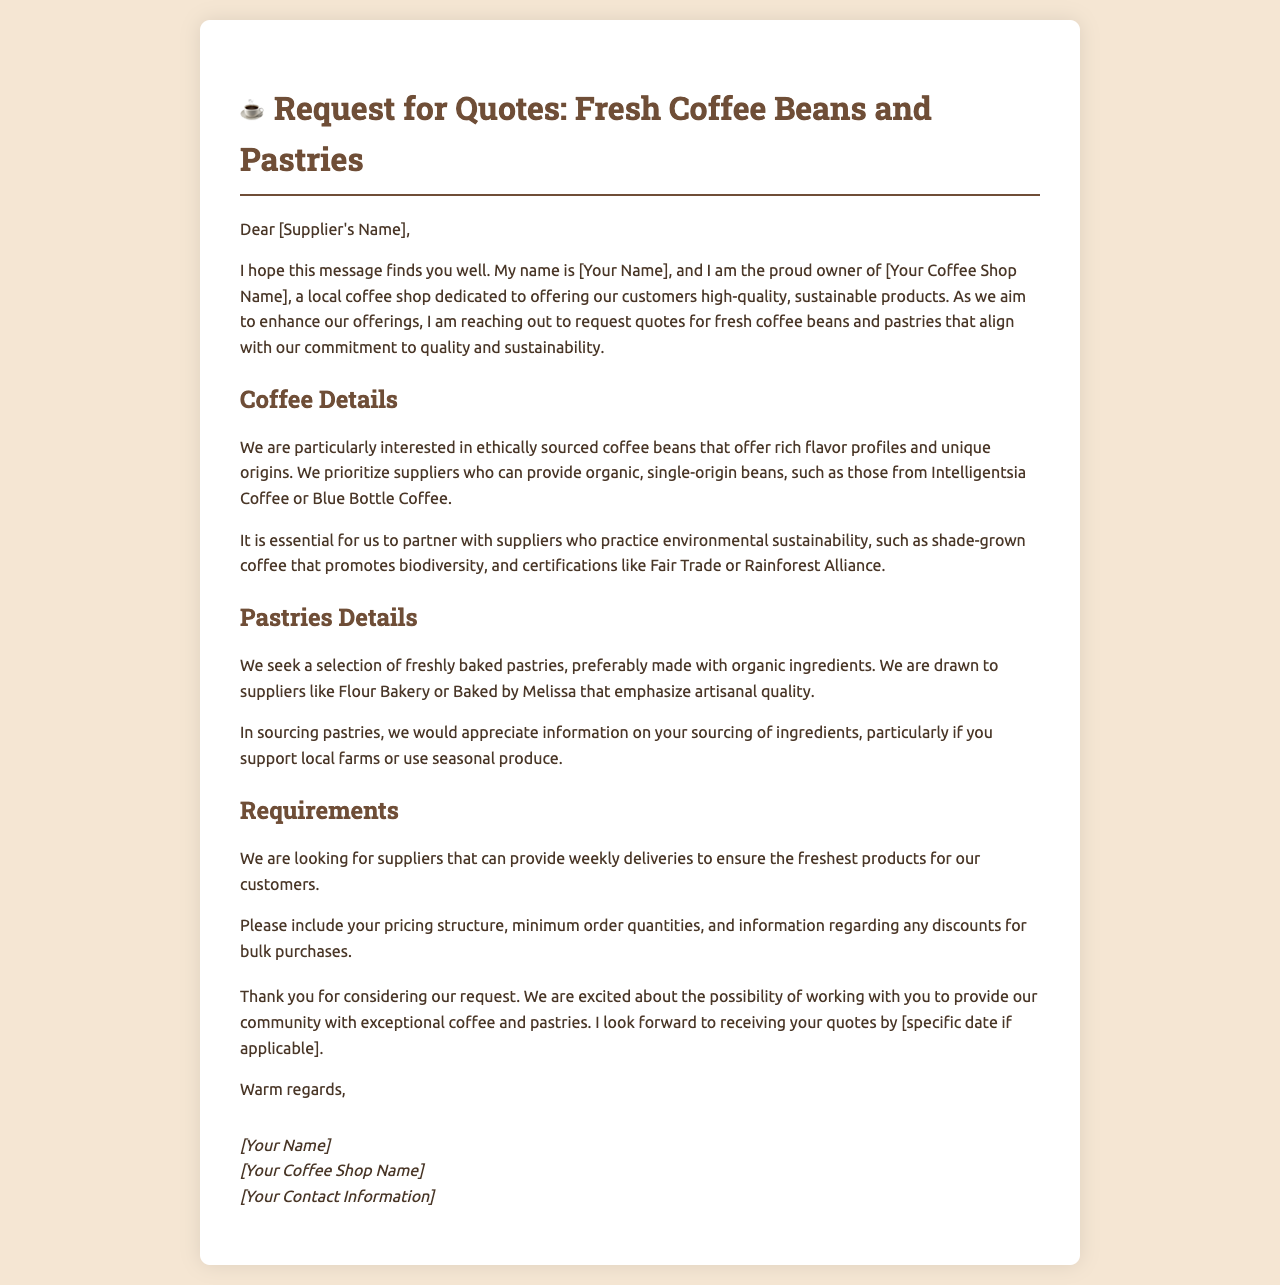what is the title of the document? The title of the document is prominently displayed at the top, summarizing the purpose of the letter.
Answer: Request for Quotes: Fresh Coffee Beans and Pastries who is the owner of the coffee shop? The owner is mentioned in the introduction segment of the letter, indicating their personal involvement.
Answer: [Your Name] what type of coffee beans is the coffee shop interested in? The letter specifies particular characteristics for the coffee beans that are sought after, emphasizing quality and sourcing methods.
Answer: ethically sourced coffee beans which organizations are mentioned as preferred suppliers of coffee beans? The letter lists two specific companies known for their quality coffee offerings.
Answer: Intelligentsia Coffee, Blue Bottle Coffee what is requested from suppliers regarding pastry ingredients? The letter outlines specific expectations surrounding the sourcing of ingredients used for pastries, ensuring they meet quality standards.
Answer: information on your sourcing of ingredients how often does the coffee shop require deliveries? The frequency of deliveries is succinctly described in the requirements section, emphasizing freshness.
Answer: weekly what is the coffee shop's stance on sustainability? The letter illustrates the coffee shop's values, specifically regarding environmental considerations in sourcing products.
Answer: commitment to quality and sustainability what type of pastries does the coffee shop prioritize? The document highlights specific attributes desired in the pastries that align with the coffee shop's brand.
Answer: freshly baked pastries what is requested in terms of pricing information? The document clearly states what kind of pricing details the coffee shop expects suppliers to provide.
Answer: pricing structure, minimum order quantities, discounts for bulk purchases 